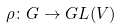<formula> <loc_0><loc_0><loc_500><loc_500>\rho \colon G \to { G L } ( V )</formula> 